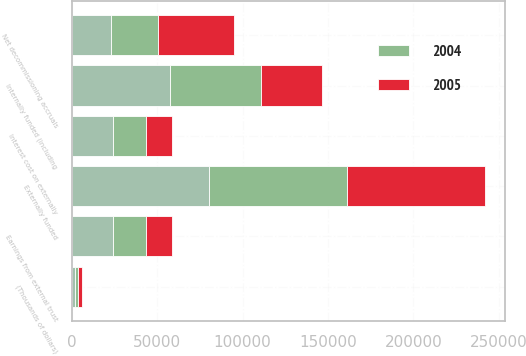Convert chart to OTSL. <chart><loc_0><loc_0><loc_500><loc_500><stacked_bar_chart><ecel><fcel>(Thousands of dollars)<fcel>Externally funded<fcel>Internally funded (including<fcel>Interest cost on externally<fcel>Earnings from external trust<fcel>Net decommissioning accruals<nl><fcel>nan<fcel>2005<fcel>80582<fcel>57561<fcel>24516<fcel>24516<fcel>23021<nl><fcel>2004<fcel>2004<fcel>80582<fcel>53307<fcel>19026<fcel>19026<fcel>27275<nl><fcel>2005<fcel>2003<fcel>80582<fcel>35906<fcel>14952<fcel>14952<fcel>44676<nl></chart> 